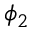<formula> <loc_0><loc_0><loc_500><loc_500>\phi _ { 2 }</formula> 